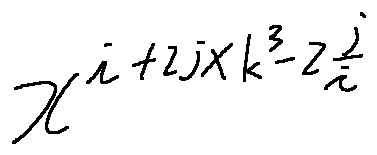Convert formula to latex. <formula><loc_0><loc_0><loc_500><loc_500>x ^ { i + 2 j \times k ^ { 3 } - 2 \frac { j } { i } }</formula> 